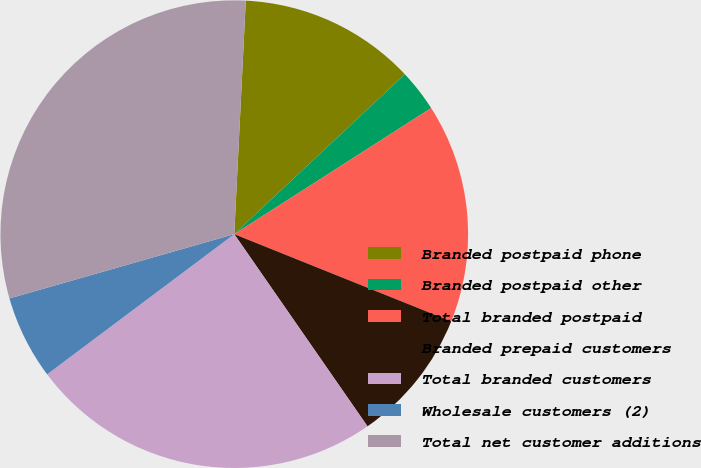Convert chart to OTSL. <chart><loc_0><loc_0><loc_500><loc_500><pie_chart><fcel>Branded postpaid phone<fcel>Branded postpaid other<fcel>Total branded postpaid<fcel>Branded prepaid customers<fcel>Total branded customers<fcel>Wholesale customers (2)<fcel>Total net customer additions<nl><fcel>12.23%<fcel>2.92%<fcel>15.15%<fcel>9.27%<fcel>24.42%<fcel>5.8%<fcel>30.22%<nl></chart> 